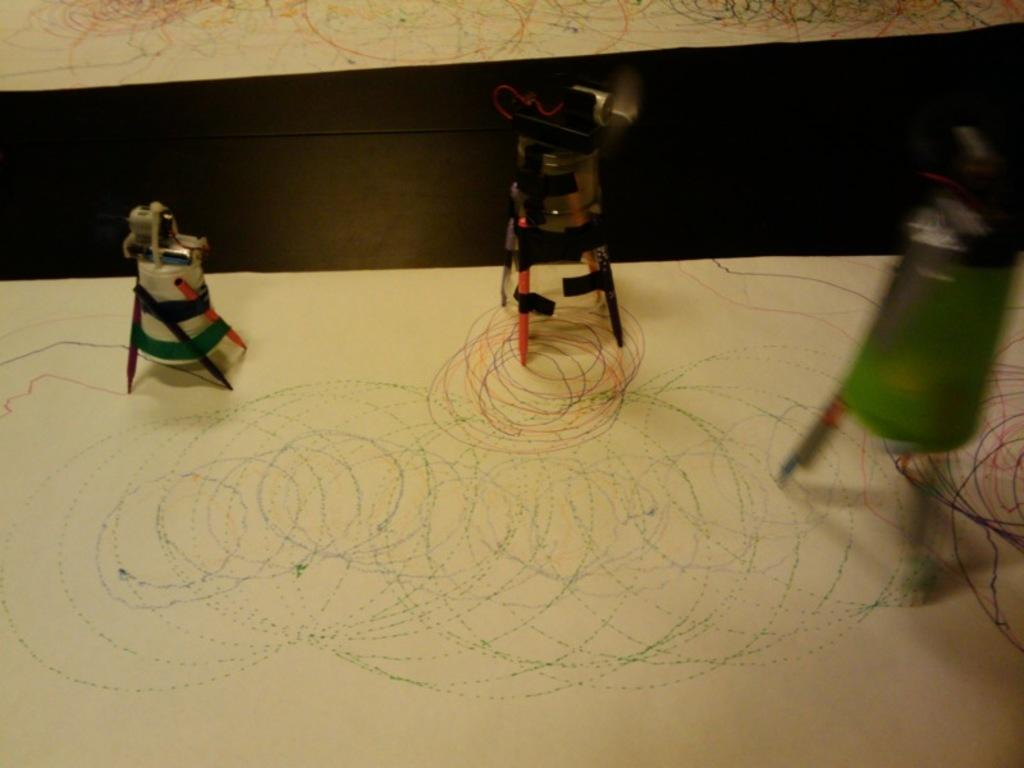What can be seen in the image? There are objects in the image. What is on the objects in the image? The objects have pencils and papers on them. Where are the pencils and papers located? The pencils and papers are on a surface. What type of insurance is being discussed in the image? There is no discussion of insurance in the image, as it features objects with pencils and papers on them. What kind of beam is supporting the objects in the image? There is no beam present in the image; the objects are on a surface. 